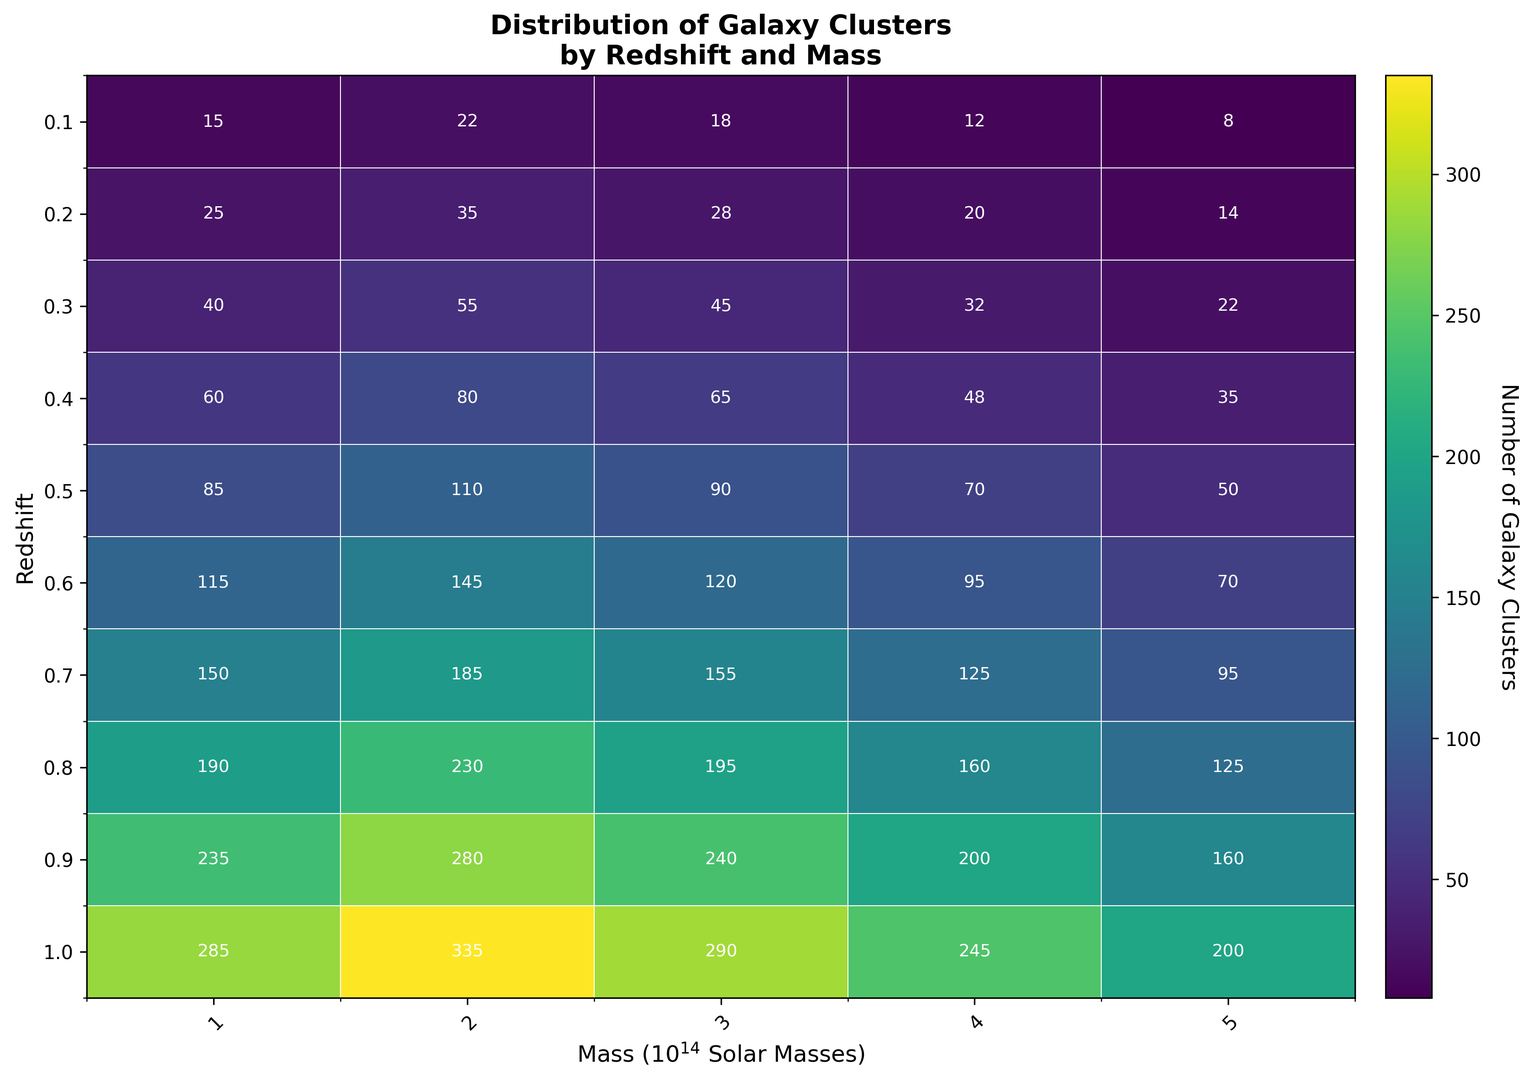What is the largest number of galaxy clusters found for a single mass and redshift combination? To find the largest number of galaxy clusters for a single mass and redshift combination, examine the heatmap and look for the highest number displayed within the cells. The highest number in the cells is 335, located at the combination of redshift 1.0 and mass 2 x 10^14 solar masses.
Answer: 335 Which mass category shows the highest number of galaxy clusters at redshift 0.6? To determine which mass category has the highest number of galaxy clusters at redshift 0.6, find the row corresponding to redshift 0.6 on the heatmap and check the values for different mass categories. The highest value is 145 at mass 2 x 10^14 solar masses.
Answer: Mass 2 x 10^14 solar masses What trend can be observed regarding the number of galaxy clusters as the redshift increases, considering the cluster count for mass 1 x 10^14 solar masses? Examine the cells in the column corresponding to mass 1 x 10^14 solar masses and observe the numbers as the redshift increases. The numbers increase steadily from 15 at redshift 0.1 up to 285 at redshift 1.0, indicating that as redshift increases, the number of galaxy clusters also increases.
Answer: Increases By how much does the number of galaxy clusters at redshift 0.9 and mass 3 x 10^14 solar masses differ from the number of clusters at redshift 0.2 and the same mass? Identify the number of clusters at redshift 0.9 (240) and at redshift 0.2 (28) for mass 3 x 10^14 solar masses. Subtract the lower value from the higher value: 240 - 28 = 212.
Answer: 212 What is the average number of galaxy clusters for redshift 0.5 across all mass categories? To find the average, sum the galaxy cluster counts for redshift 0.5 (85 + 110 + 90 + 70 + 50 = 405) and divide by the number of mass categories (5). The average is 405/5 = 81.
Answer: 81 How does the number of galaxy clusters for mass 5 x 10^14 solar masses change from redshift 0.1 to redshift 1.0? Check the values for mass 5 x 10^14 solar masses across the redshift spectrum: 8 (redshift 0.1), 14 (0.2), 22 (0.3), 35 (0.4), 50 (0.5), 70 (0.6), 95 (0.7), 125 (0.8), 160 (0.9), and 200 (1.0). The number increases consistently as redshift increases from 0.1 to 1.0.
Answer: Increases Which redshift has the smallest number of galaxy clusters for mass 4 x 10^14 solar masses and what is the value? Locate the column for mass 4 x 10^14 solar masses and identify the smallest value across all redshifts. The smallest number is 12 at redshift 0.1.
Answer: 12 at redshift 0.1 Compare the number of galaxy clusters at redshift 0.4 for mass 2 x 10^14 solar masses with the number at redshift 0.7 for the same mass. Which one is higher, and by what amount? Determine the cluster counts: 80 (redshift 0.4) and 185 (redshift 0.7) for mass 2 x 10^14 solar masses. The number at redshift 0.7 is higher by 185 - 80 = 105.
Answer: 105 more at redshift 0.7 